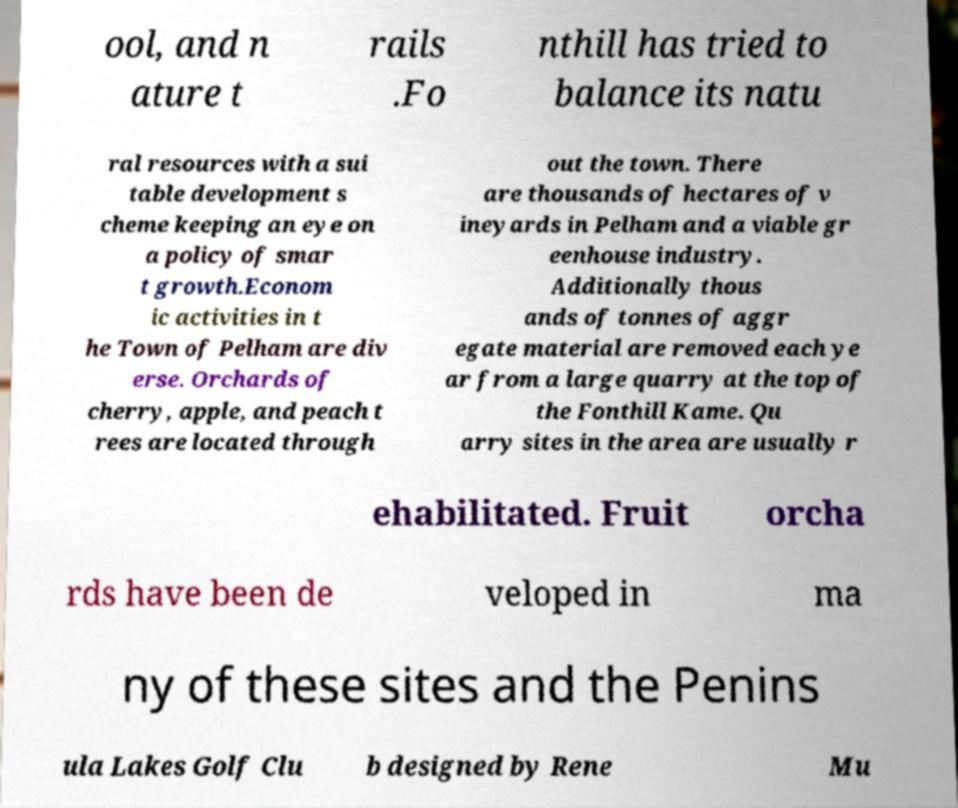What messages or text are displayed in this image? I need them in a readable, typed format. ool, and n ature t rails .Fo nthill has tried to balance its natu ral resources with a sui table development s cheme keeping an eye on a policy of smar t growth.Econom ic activities in t he Town of Pelham are div erse. Orchards of cherry, apple, and peach t rees are located through out the town. There are thousands of hectares of v ineyards in Pelham and a viable gr eenhouse industry. Additionally thous ands of tonnes of aggr egate material are removed each ye ar from a large quarry at the top of the Fonthill Kame. Qu arry sites in the area are usually r ehabilitated. Fruit orcha rds have been de veloped in ma ny of these sites and the Penins ula Lakes Golf Clu b designed by Rene Mu 